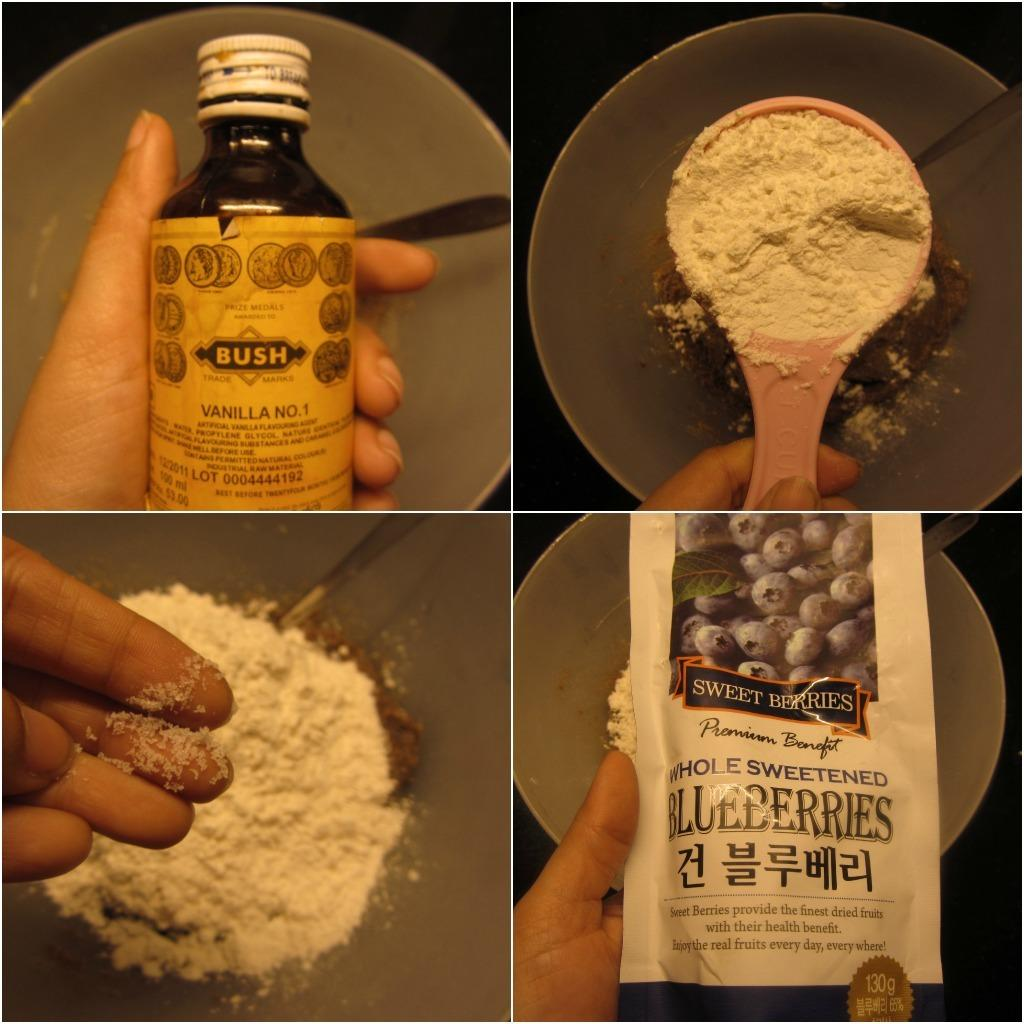Provide a one-sentence caption for the provided image. A person shows ingredients such as vanilla and blueberries being added to a mixing bowl. 